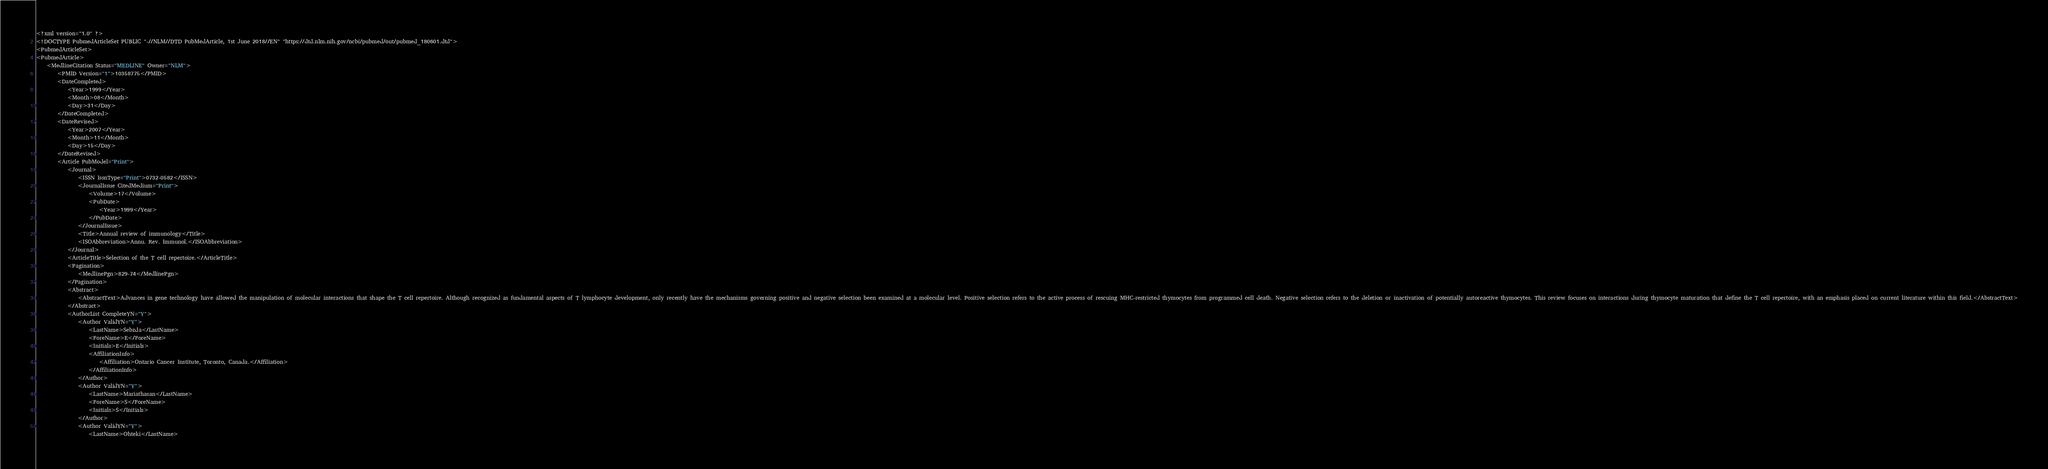Convert code to text. <code><loc_0><loc_0><loc_500><loc_500><_XML_><?xml version="1.0" ?>
<!DOCTYPE PubmedArticleSet PUBLIC "-//NLM//DTD PubMedArticle, 1st June 2018//EN" "https://dtd.nlm.nih.gov/ncbi/pubmed/out/pubmed_180601.dtd">
<PubmedArticleSet>
<PubmedArticle>
    <MedlineCitation Status="MEDLINE" Owner="NLM">
        <PMID Version="1">10358775</PMID>
        <DateCompleted>
            <Year>1999</Year>
            <Month>08</Month>
            <Day>31</Day>
        </DateCompleted>
        <DateRevised>
            <Year>2007</Year>
            <Month>11</Month>
            <Day>15</Day>
        </DateRevised>
        <Article PubModel="Print">
            <Journal>
                <ISSN IssnType="Print">0732-0582</ISSN>
                <JournalIssue CitedMedium="Print">
                    <Volume>17</Volume>
                    <PubDate>
                        <Year>1999</Year>
                    </PubDate>
                </JournalIssue>
                <Title>Annual review of immunology</Title>
                <ISOAbbreviation>Annu. Rev. Immunol.</ISOAbbreviation>
            </Journal>
            <ArticleTitle>Selection of the T cell repertoire.</ArticleTitle>
            <Pagination>
                <MedlinePgn>829-74</MedlinePgn>
            </Pagination>
            <Abstract>
                <AbstractText>Advances in gene technology have allowed the manipulation of molecular interactions that shape the T cell repertoire. Although recognized as fundamental aspects of T lymphocyte development, only recently have the mechanisms governing positive and negative selection been examined at a molecular level. Positive selection refers to the active process of rescuing MHC-restricted thymocytes from programmed cell death. Negative selection refers to the deletion or inactivation of potentially autoreactive thymocytes. This review focuses on interactions during thymocyte maturation that define the T cell repertoire, with an emphasis placed on current literature within this field.</AbstractText>
            </Abstract>
            <AuthorList CompleteYN="Y">
                <Author ValidYN="Y">
                    <LastName>Sebzda</LastName>
                    <ForeName>E</ForeName>
                    <Initials>E</Initials>
                    <AffiliationInfo>
                        <Affiliation>Ontario Cancer Institute, Toronto, Canada.</Affiliation>
                    </AffiliationInfo>
                </Author>
                <Author ValidYN="Y">
                    <LastName>Mariathasan</LastName>
                    <ForeName>S</ForeName>
                    <Initials>S</Initials>
                </Author>
                <Author ValidYN="Y">
                    <LastName>Ohteki</LastName></code> 